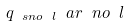Convert formula to latex. <formula><loc_0><loc_0><loc_500><loc_500>q _ { \ s n o \ l } \ a r \ n o \ l</formula> 